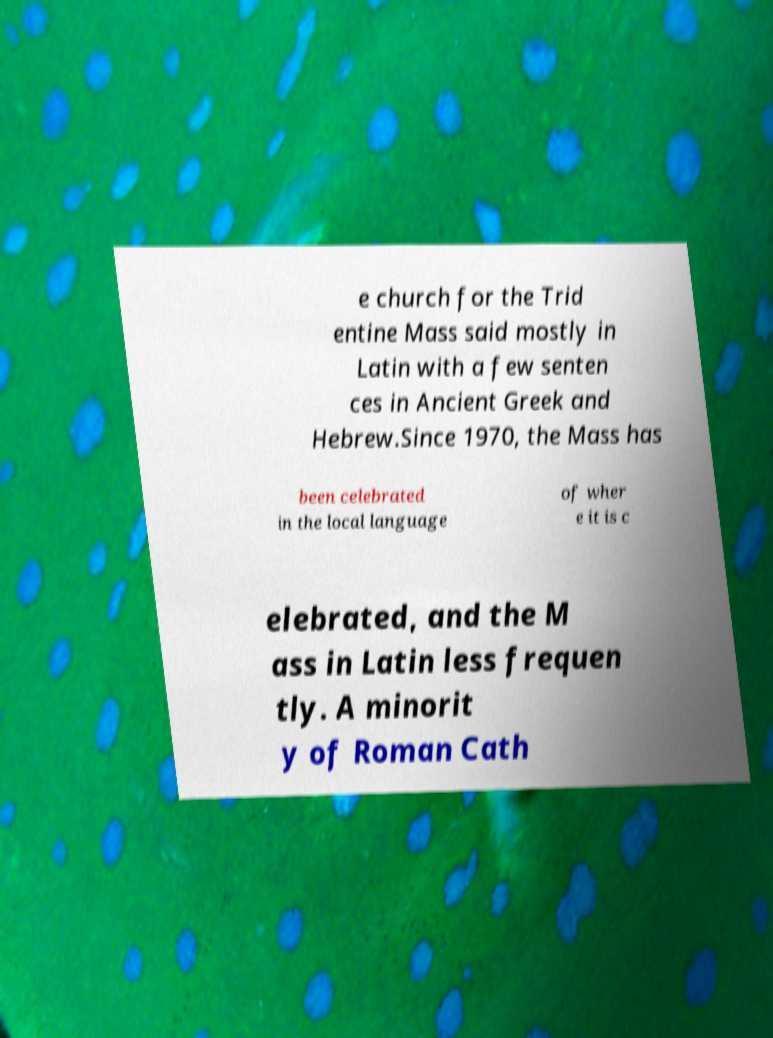Could you assist in decoding the text presented in this image and type it out clearly? e church for the Trid entine Mass said mostly in Latin with a few senten ces in Ancient Greek and Hebrew.Since 1970, the Mass has been celebrated in the local language of wher e it is c elebrated, and the M ass in Latin less frequen tly. A minorit y of Roman Cath 